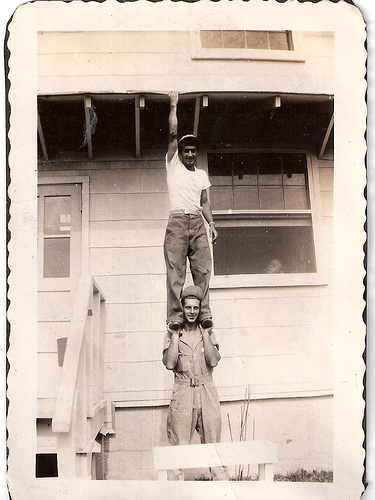<image>
Is there a black man on the white man? Yes. Looking at the image, I can see the black man is positioned on top of the white man, with the white man providing support. 